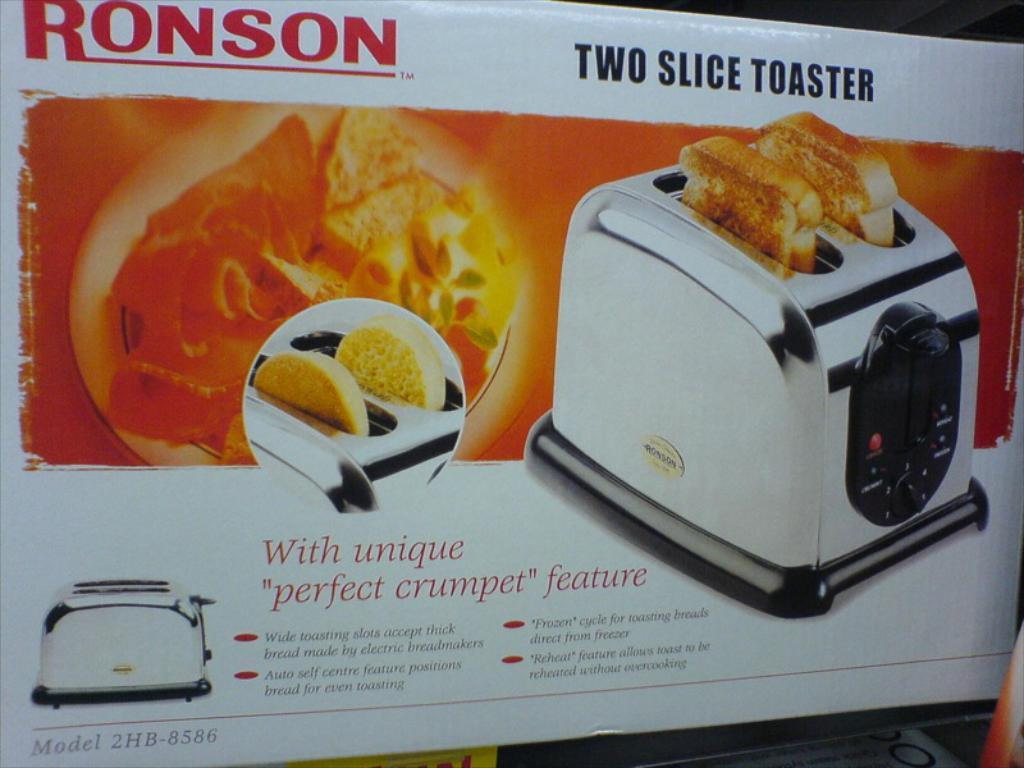<image>
Offer a succinct explanation of the picture presented. a toaster box with the brand of Ronson on it 